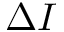<formula> <loc_0><loc_0><loc_500><loc_500>\Delta I</formula> 